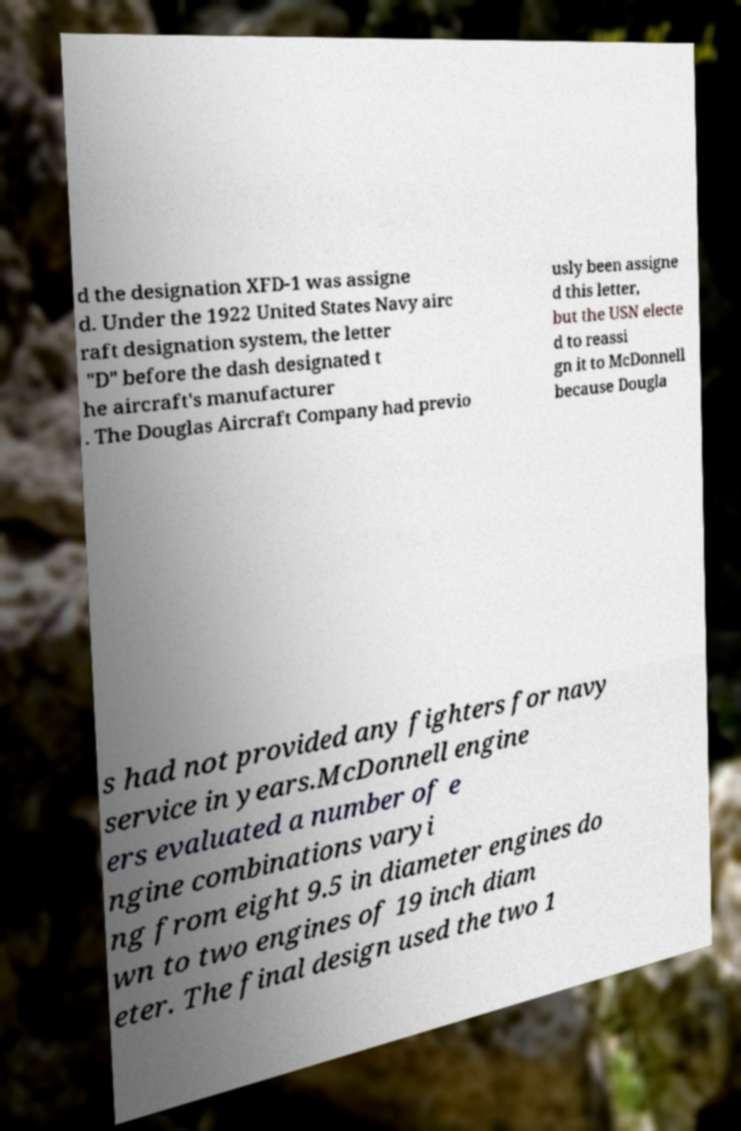Please read and relay the text visible in this image. What does it say? d the designation XFD-1 was assigne d. Under the 1922 United States Navy airc raft designation system, the letter "D" before the dash designated t he aircraft's manufacturer . The Douglas Aircraft Company had previo usly been assigne d this letter, but the USN electe d to reassi gn it to McDonnell because Dougla s had not provided any fighters for navy service in years.McDonnell engine ers evaluated a number of e ngine combinations varyi ng from eight 9.5 in diameter engines do wn to two engines of 19 inch diam eter. The final design used the two 1 